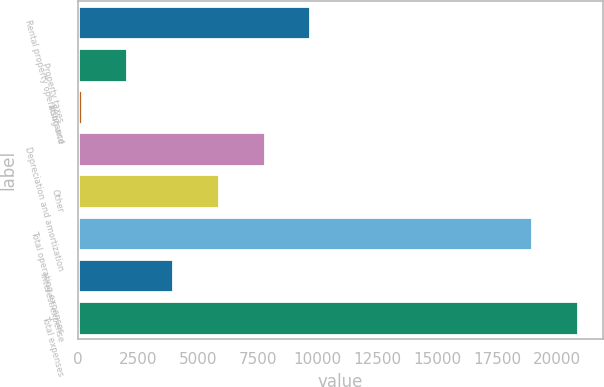Convert chart to OTSL. <chart><loc_0><loc_0><loc_500><loc_500><bar_chart><fcel>Rental property operating and<fcel>Property taxes<fcel>Insurance<fcel>Depreciation and amortization<fcel>Other<fcel>Total operating expenses<fcel>Interest expense<fcel>Total expenses<nl><fcel>9689<fcel>2056.2<fcel>148<fcel>7780.8<fcel>5872.6<fcel>18932<fcel>3964.4<fcel>20840.2<nl></chart> 